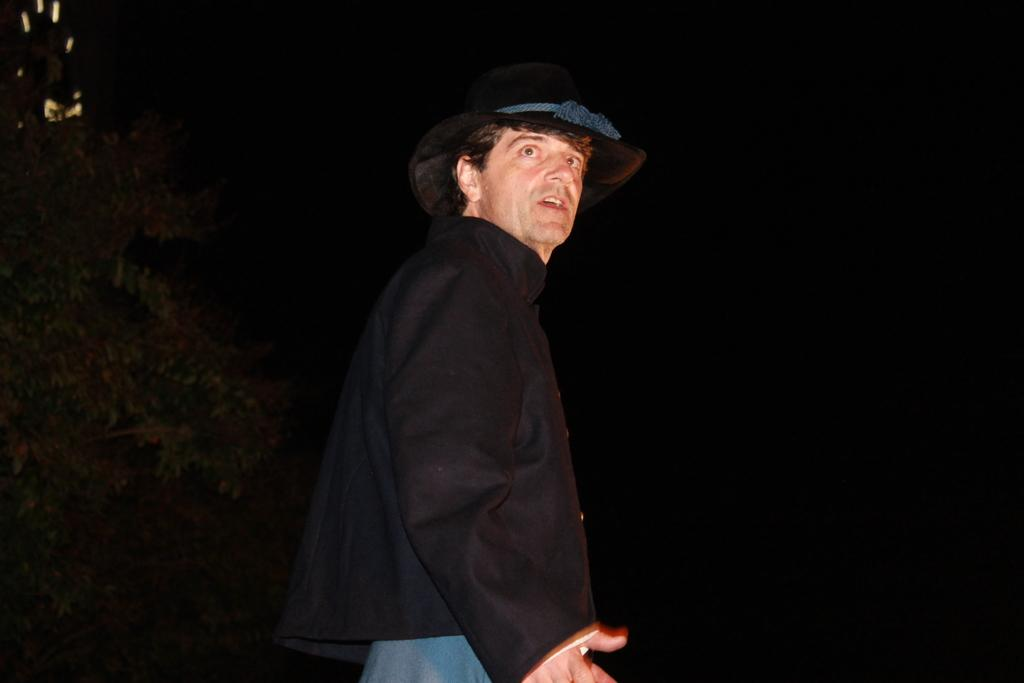Who is the main subject in the image? There is a person in the center of the image. What is the person wearing? The person is wearing a black dress and a hat. What can be observed about the background of the image? The background of the image is dark. What type of plantation can be seen in the background of the image? There is no plantation present in the image; the background is dark. 